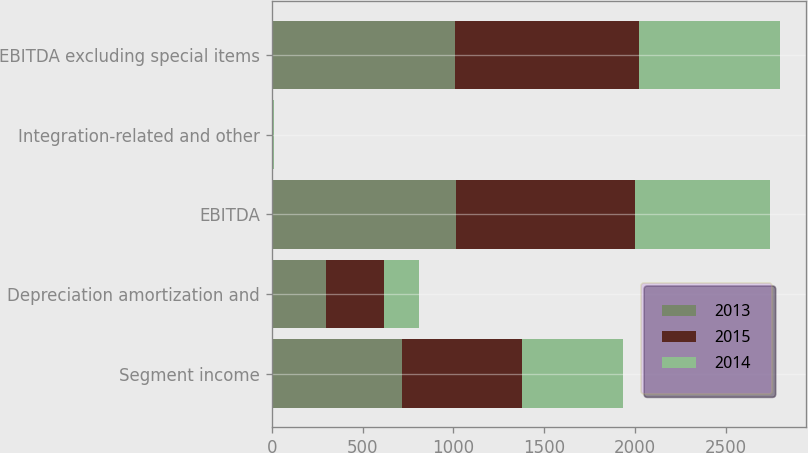Convert chart to OTSL. <chart><loc_0><loc_0><loc_500><loc_500><stacked_bar_chart><ecel><fcel>Segment income<fcel>Depreciation amortization and<fcel>EBITDA<fcel>Integration-related and other<fcel>EBITDA excluding special items<nl><fcel>2013<fcel>714.9<fcel>297.3<fcel>1012.2<fcel>4.1<fcel>1009.3<nl><fcel>2015<fcel>663.2<fcel>323<fcel>986.2<fcel>4.9<fcel>1015<nl><fcel>2014<fcel>554.2<fcel>190.2<fcel>744.4<fcel>1.4<fcel>774.7<nl></chart> 